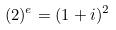<formula> <loc_0><loc_0><loc_500><loc_500>( 2 ) ^ { e } = ( 1 + i ) ^ { 2 }</formula> 